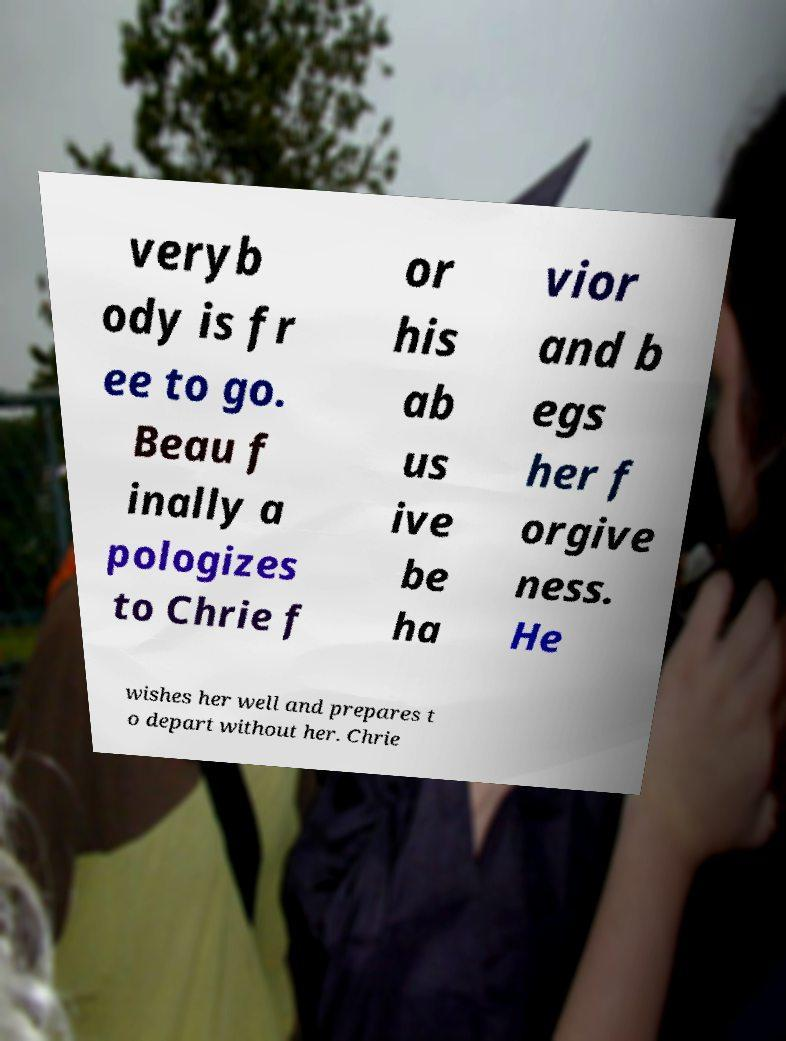Could you extract and type out the text from this image? veryb ody is fr ee to go. Beau f inally a pologizes to Chrie f or his ab us ive be ha vior and b egs her f orgive ness. He wishes her well and prepares t o depart without her. Chrie 